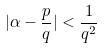<formula> <loc_0><loc_0><loc_500><loc_500>| \alpha - \frac { p } { q } | < \frac { 1 } { q ^ { 2 } }</formula> 